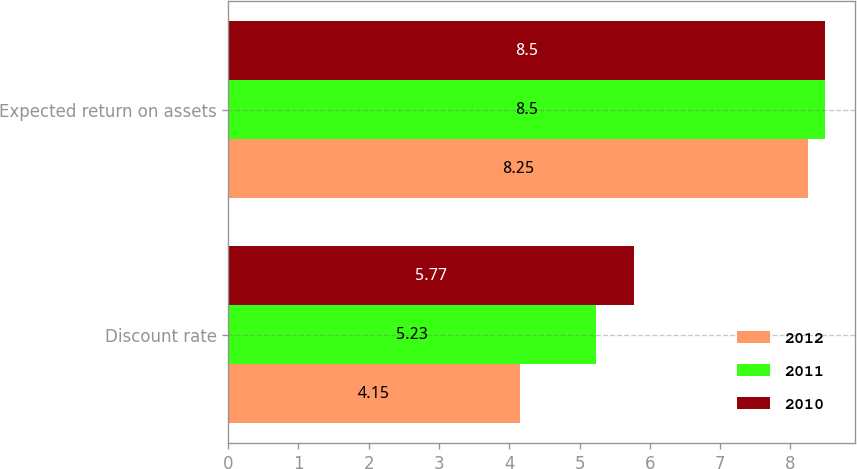Convert chart. <chart><loc_0><loc_0><loc_500><loc_500><stacked_bar_chart><ecel><fcel>Discount rate<fcel>Expected return on assets<nl><fcel>2012<fcel>4.15<fcel>8.25<nl><fcel>2011<fcel>5.23<fcel>8.5<nl><fcel>2010<fcel>5.77<fcel>8.5<nl></chart> 